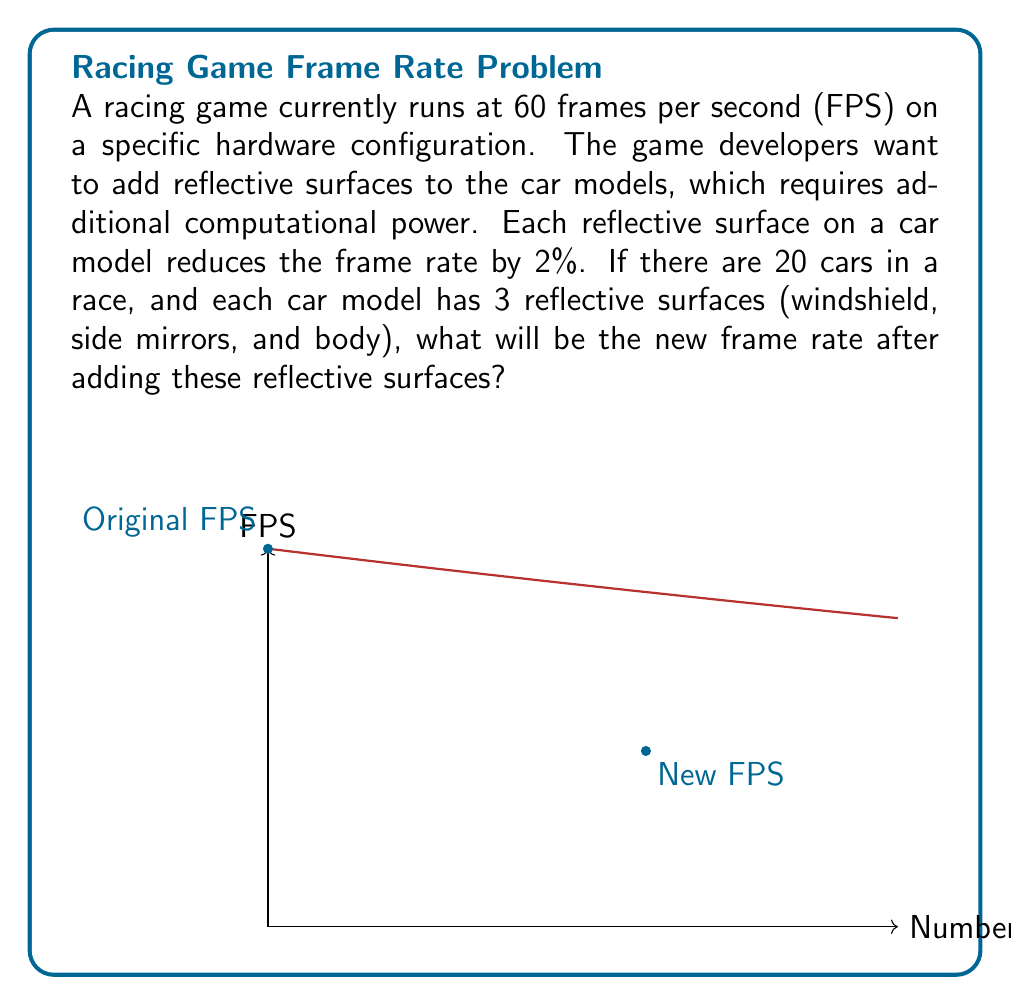What is the answer to this math problem? Let's approach this step-by-step:

1) First, we need to calculate the total number of reflective surfaces:
   $$ \text{Total surfaces} = \text{Number of cars} \times \text{Surfaces per car} $$
   $$ \text{Total surfaces} = 20 \times 3 = 60 \text{ surfaces} $$

2) Each surface reduces the frame rate by 2%. We can represent this as a multiplier:
   $$ \text{Frame rate multiplier per surface} = 1 - 0.02 = 0.98 $$

3) For all 60 surfaces, we need to apply this multiplier 60 times:
   $$ \text{Total frame rate multiplier} = 0.98^{60} $$

4) We can calculate this using a calculator or computer:
   $$ 0.98^{60} \approx 0.2988 $$

5) Now, we can calculate the new frame rate:
   $$ \text{New FPS} = \text{Original FPS} \times \text{Total frame rate multiplier} $$
   $$ \text{New FPS} = 60 \times 0.2988 \approx 17.93 \text{ FPS} $$

6) Rounding to the nearest whole number (as FPS is typically reported as an integer):
   $$ \text{New FPS} \approx 18 \text{ FPS} $$
Answer: 18 FPS 